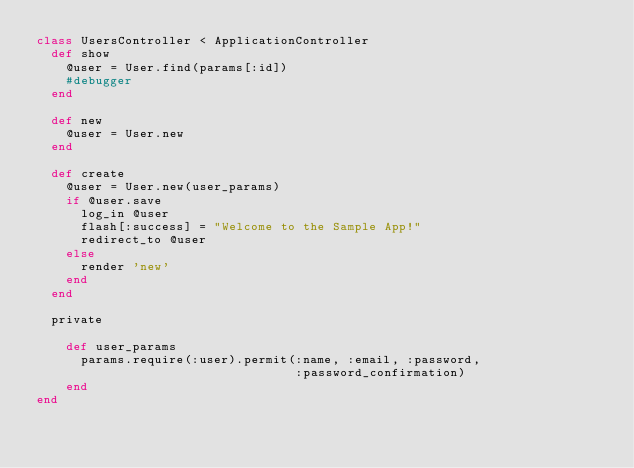Convert code to text. <code><loc_0><loc_0><loc_500><loc_500><_Ruby_>class UsersController < ApplicationController
  def show
    @user = User.find(params[:id])
    #debugger
  end
  
  def new
    @user = User.new
  end

  def create
    @user = User.new(user_params)
    if @user.save
      log_in @user
      flash[:success] = "Welcome to the Sample App!"
      redirect_to @user
    else
      render 'new'
    end
  end
  
  private
  
    def user_params
      params.require(:user).permit(:name, :email, :password,
                                   :password_confirmation)
    end
end
</code> 